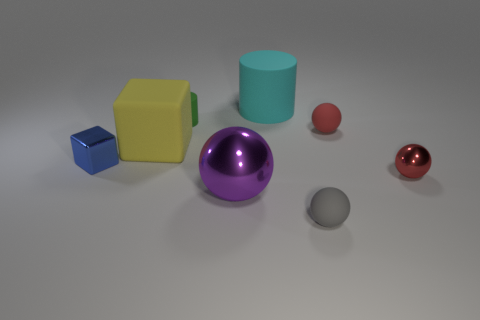Subtract all small spheres. How many spheres are left? 1 Add 1 matte cubes. How many objects exist? 9 Subtract 1 cylinders. How many cylinders are left? 1 Subtract all yellow blocks. How many blocks are left? 1 Subtract all blue cubes. How many red balls are left? 2 Subtract all cubes. How many objects are left? 6 Subtract all green cylinders. Subtract all yellow blocks. How many cylinders are left? 1 Subtract all purple metallic spheres. Subtract all big rubber things. How many objects are left? 5 Add 8 small metallic things. How many small metallic things are left? 10 Add 8 tiny red matte things. How many tiny red matte things exist? 9 